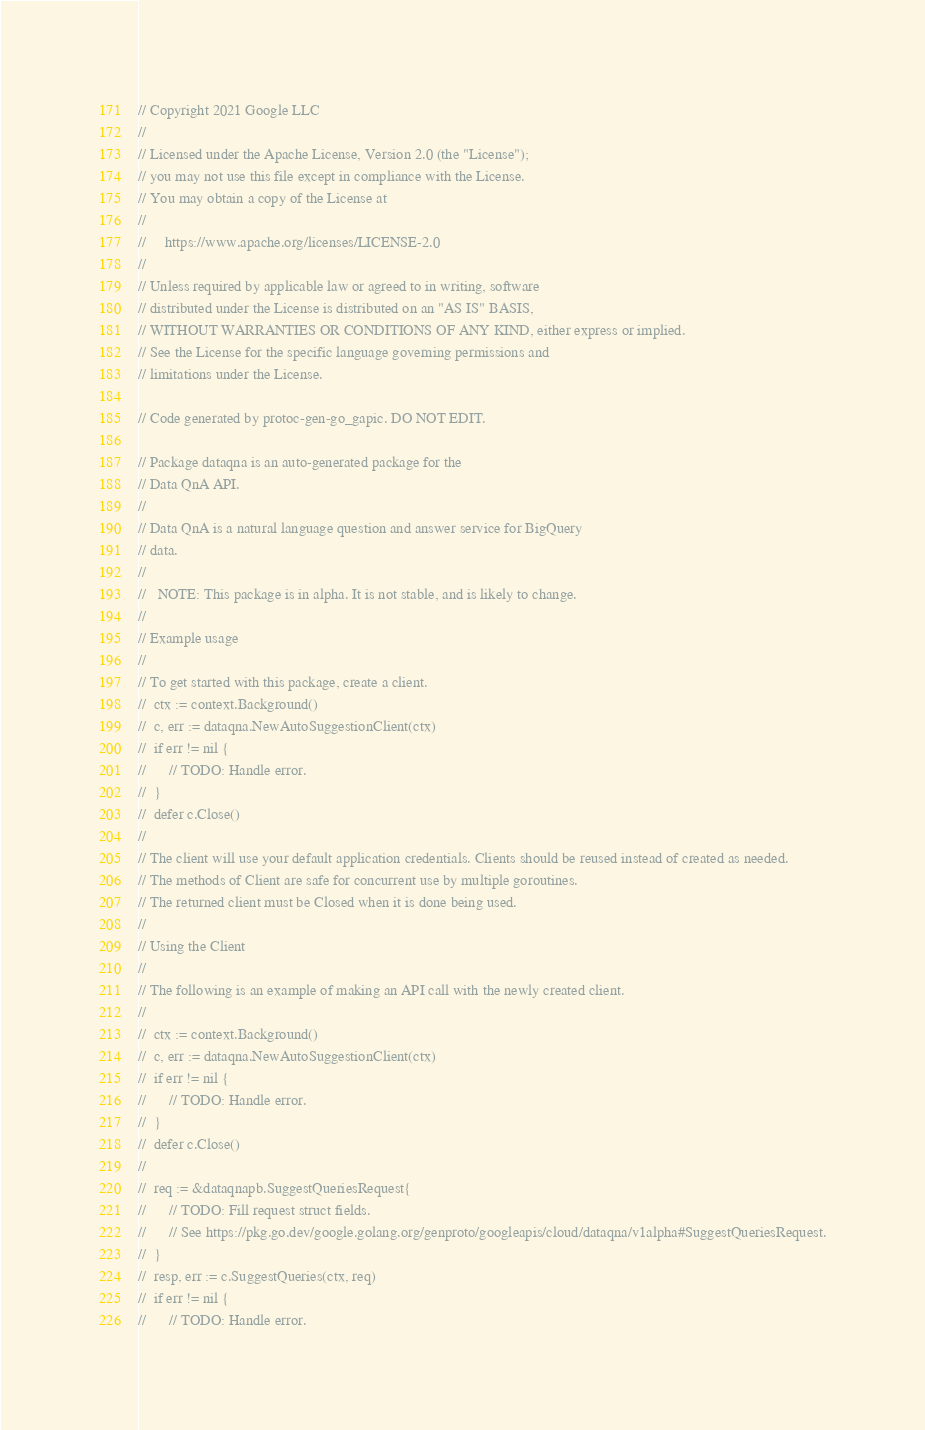Convert code to text. <code><loc_0><loc_0><loc_500><loc_500><_Go_>// Copyright 2021 Google LLC
//
// Licensed under the Apache License, Version 2.0 (the "License");
// you may not use this file except in compliance with the License.
// You may obtain a copy of the License at
//
//     https://www.apache.org/licenses/LICENSE-2.0
//
// Unless required by applicable law or agreed to in writing, software
// distributed under the License is distributed on an "AS IS" BASIS,
// WITHOUT WARRANTIES OR CONDITIONS OF ANY KIND, either express or implied.
// See the License for the specific language governing permissions and
// limitations under the License.

// Code generated by protoc-gen-go_gapic. DO NOT EDIT.

// Package dataqna is an auto-generated package for the
// Data QnA API.
//
// Data QnA is a natural language question and answer service for BigQuery
// data.
//
//   NOTE: This package is in alpha. It is not stable, and is likely to change.
//
// Example usage
//
// To get started with this package, create a client.
//  ctx := context.Background()
//  c, err := dataqna.NewAutoSuggestionClient(ctx)
//  if err != nil {
//  	// TODO: Handle error.
//  }
//  defer c.Close()
//
// The client will use your default application credentials. Clients should be reused instead of created as needed.
// The methods of Client are safe for concurrent use by multiple goroutines.
// The returned client must be Closed when it is done being used.
//
// Using the Client
//
// The following is an example of making an API call with the newly created client.
//
//  ctx := context.Background()
//  c, err := dataqna.NewAutoSuggestionClient(ctx)
//  if err != nil {
//  	// TODO: Handle error.
//  }
//  defer c.Close()
//
//  req := &dataqnapb.SuggestQueriesRequest{
//  	// TODO: Fill request struct fields.
//  	// See https://pkg.go.dev/google.golang.org/genproto/googleapis/cloud/dataqna/v1alpha#SuggestQueriesRequest.
//  }
//  resp, err := c.SuggestQueries(ctx, req)
//  if err != nil {
//  	// TODO: Handle error.</code> 